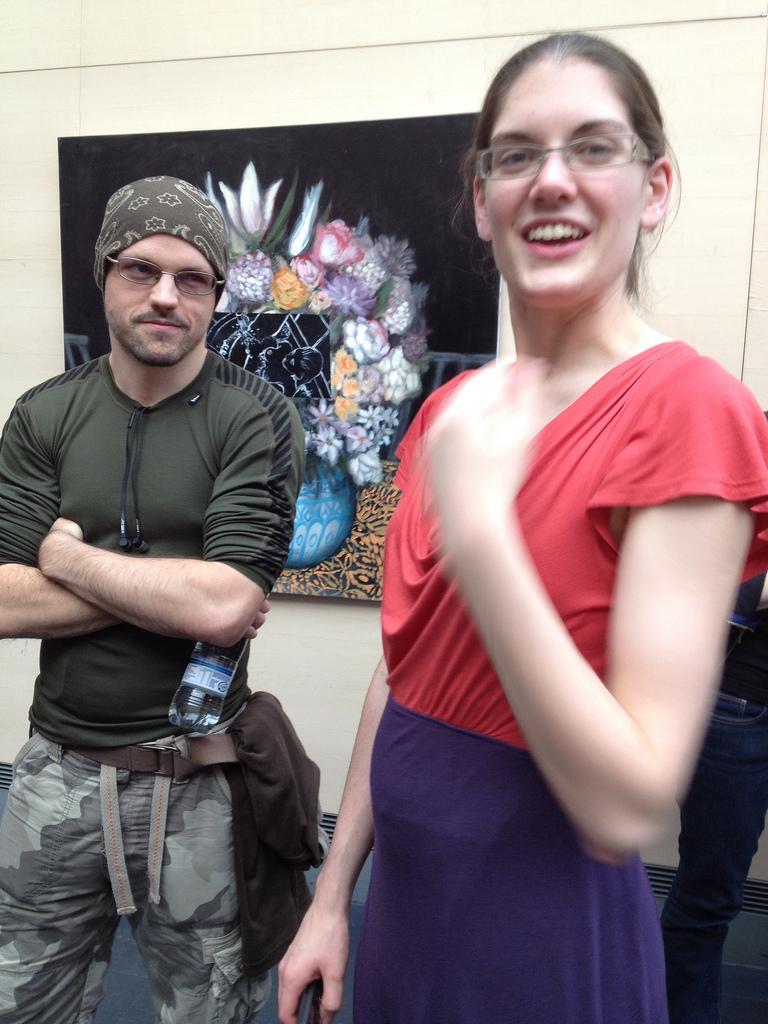Could you give a brief overview of what you see in this image? In the center of the image we can see a man and a lady standing. In the background there is a wall frame placed on the wall. 